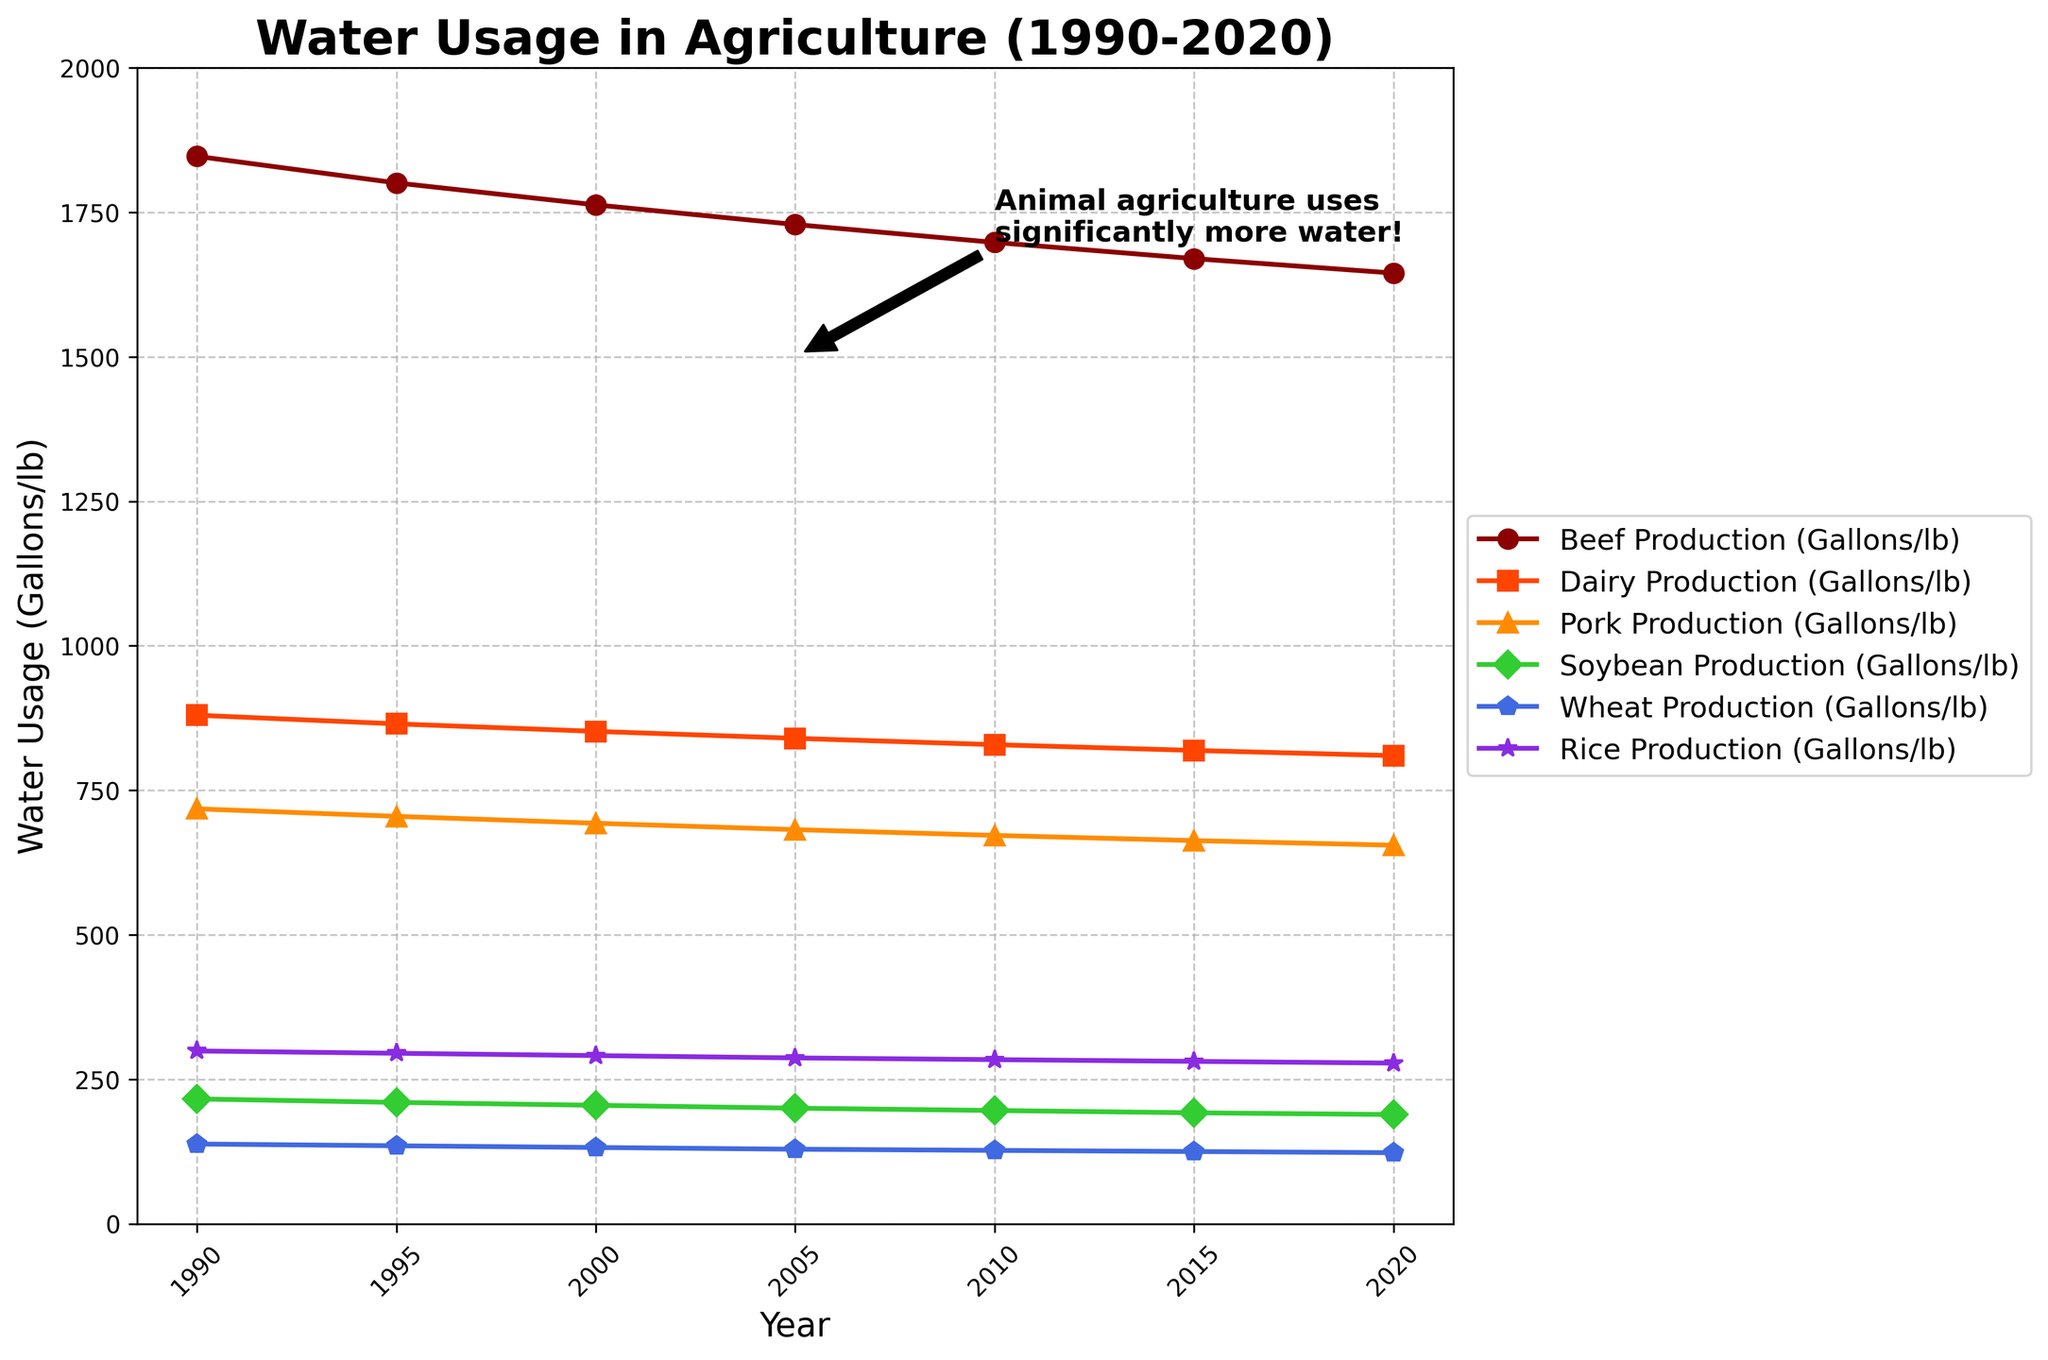Which type of agriculture used the most water in 1990? From the figure, look at the leftmost points for each type of agriculture. The highest point in 1990 is for Beef Production at approximately 1847 gallons/lb.
Answer: Beef Production What is the trend in water usage for Soybean Production from 1990 to 2020? Track the line corresponding to Soybean Production from 1990 to 2020. The data shows a gradual decrease from 216 gallons/lb in 1990 to 189 gallons/lb in 2020.
Answer: Decreasing Which agricultural product had the highest water usage in 2020? Look at the rightmost points for each type of agriculture in 2020. Beef Production is the highest at 1645 gallons/lb.
Answer: Beef Production By how much did the water usage for Dairy Production decrease between 1990 and 2020? Subtract the water usage for Dairy Production in 2020 (810 gallons/lb) from that in 1990 (880 gallons/lb). The difference is 880 - 810 = 70 gallons/lb.
Answer: 70 gallons/lb Compare the water usage of Pork Production and Soybean Production in 2020. Look at the rightmost points for Pork Production and Soybean Production. Pork Production is at 655 gallons/lb, and Soybean Production is at 189 gallons/lb. Pork Production uses significantly more water.
Answer: Pork Production uses more What is the average water usage for Wheat Production over the years shown? Sum the water usage for Wheat Production for all years (138 + 135 + 132 + 129 + 127 + 125 + 123) = 909. Divide by the number of data points (7). The average is 909/7 ≈ 130.
Answer: 130 gallons/lb Which type of agriculture saw the least decrease in water usage from 1990 to 2020? Calculate the decrease for each type from 1990 to 2020. Beef: 1847-1645=202, Dairy: 880-810=70, Pork: 718-655=63, Soybean: 216-189=27, Wheat: 138-123=15, Rice: 299-278=21. Soybean shows the least decrease.
Answer: Soybean Production How did the water usage for Rice Production change from 2000 to 2020? Find the data points for Rice Production in 2000 (291 gallons/lb) and 2020 (278 gallons/lb). The change is 291 - 278 = 13 gallons/lb decrease.
Answer: Decreased by 13 gallons/lb What visual indicator helps highlight the difference in water usage between animal and plant-based agriculture? The figure includes an annotation pointing out that "Animal agriculture uses significantly more water!" with an arrow pointing to the animal agriculture lines.
Answer: Annotation and arrow Which trend is depicted by the orange line in the figure? The orange line depicts Dairy Production. From 1990 to 2020, it shows a downward trend, indicating a decrease in water usage from 880 to 810 gallons/lb.
Answer: Downward trend 